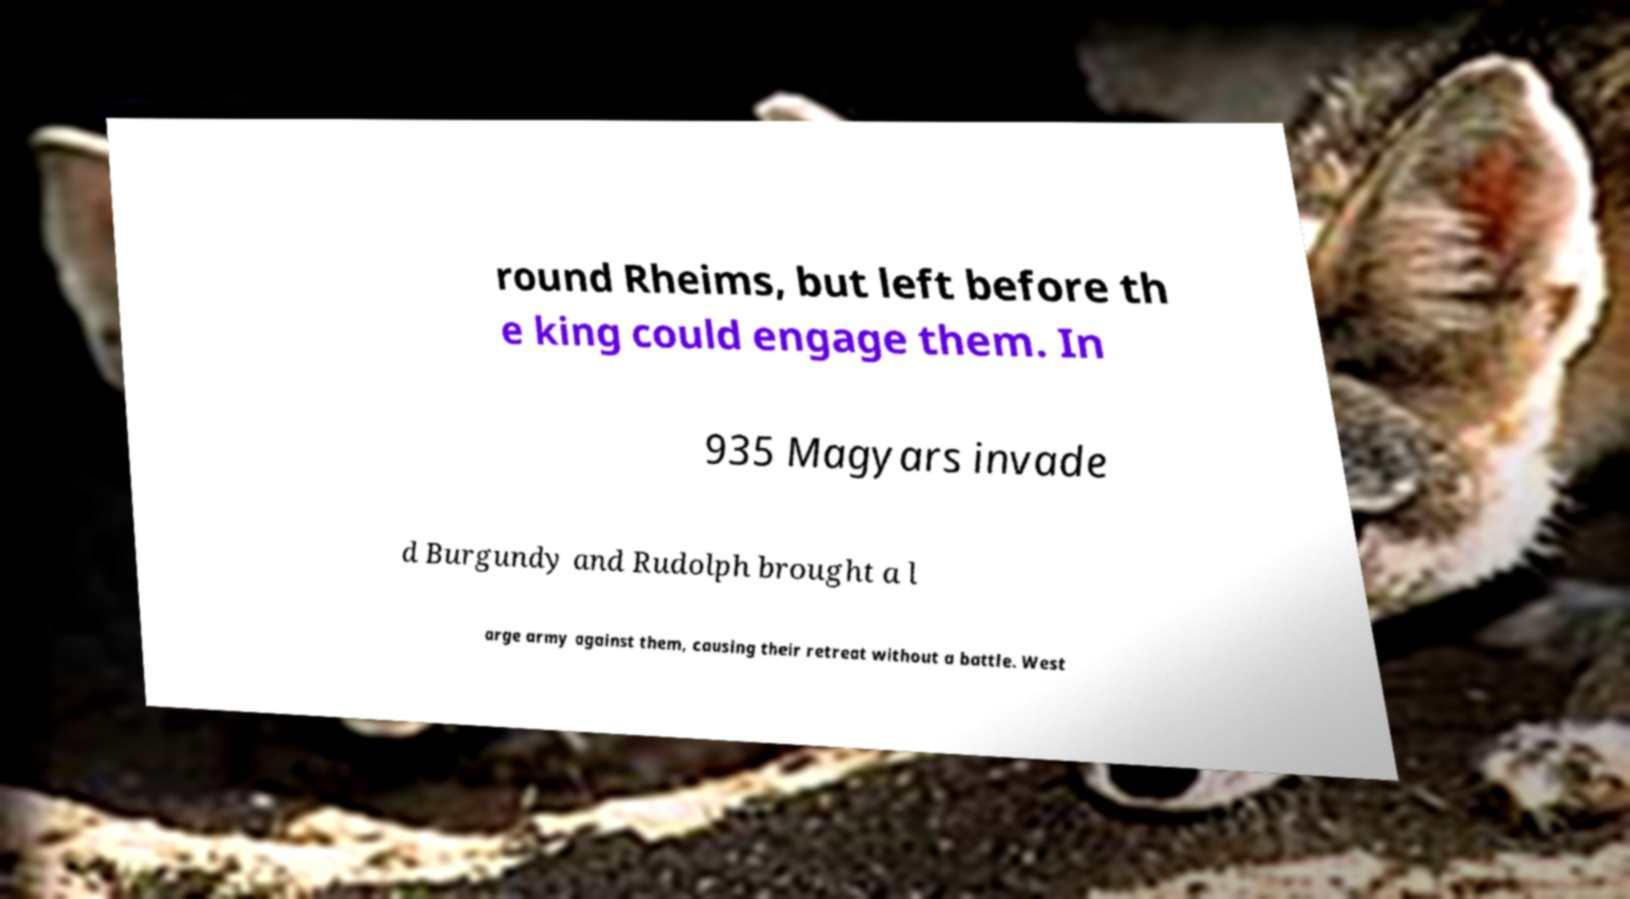Please identify and transcribe the text found in this image. round Rheims, but left before th e king could engage them. In 935 Magyars invade d Burgundy and Rudolph brought a l arge army against them, causing their retreat without a battle. West 